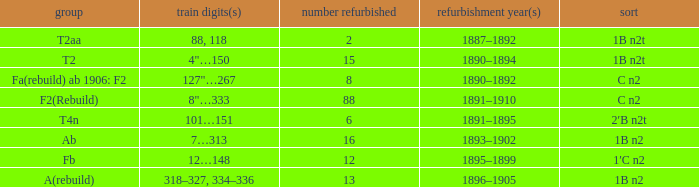Help me parse the entirety of this table. {'header': ['group', 'train digits(s)', 'number refurbished', 'refurbishment year(s)', 'sort'], 'rows': [['T2aa', '88, 118', '2', '1887–1892', '1B n2t'], ['T2', '4"…150', '15', '1890–1894', '1B n2t'], ['Fa(rebuild) ab 1906: F2', '127"…267', '8', '1890–1892', 'C n2'], ['F2(Rebuild)', '8"…333', '88', '1891–1910', 'C n2'], ['T4n', '101…151', '6', '1891–1895', '2′B n2t'], ['Ab', '7…313', '16', '1893–1902', '1B n2'], ['Fb', '12…148', '12', '1895–1899', '1′C n2'], ['A(rebuild)', '318–327, 334–336', '13', '1896–1905', '1B n2']]} What was the Rebuildjahr(e) for the T2AA class? 1887–1892. 